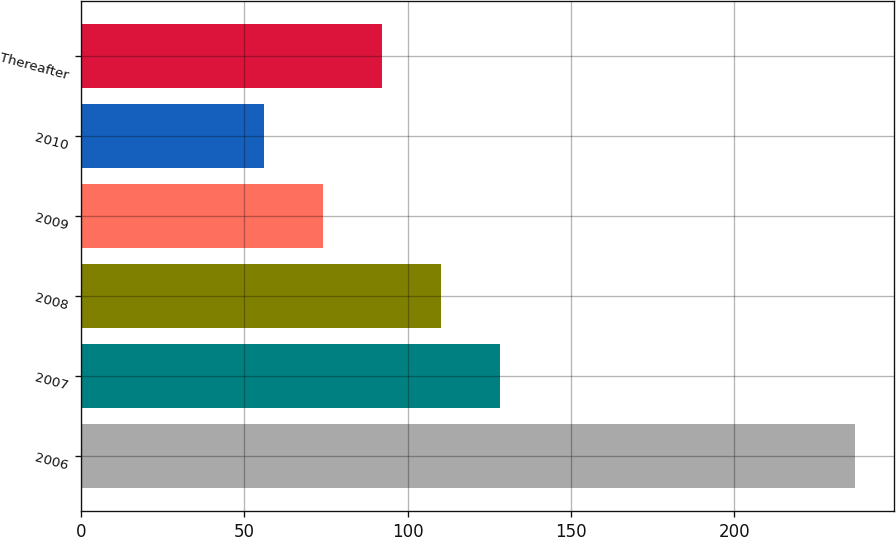Convert chart. <chart><loc_0><loc_0><loc_500><loc_500><bar_chart><fcel>2006<fcel>2007<fcel>2008<fcel>2009<fcel>2010<fcel>Thereafter<nl><fcel>237<fcel>128.4<fcel>110.3<fcel>74.1<fcel>56<fcel>92.2<nl></chart> 